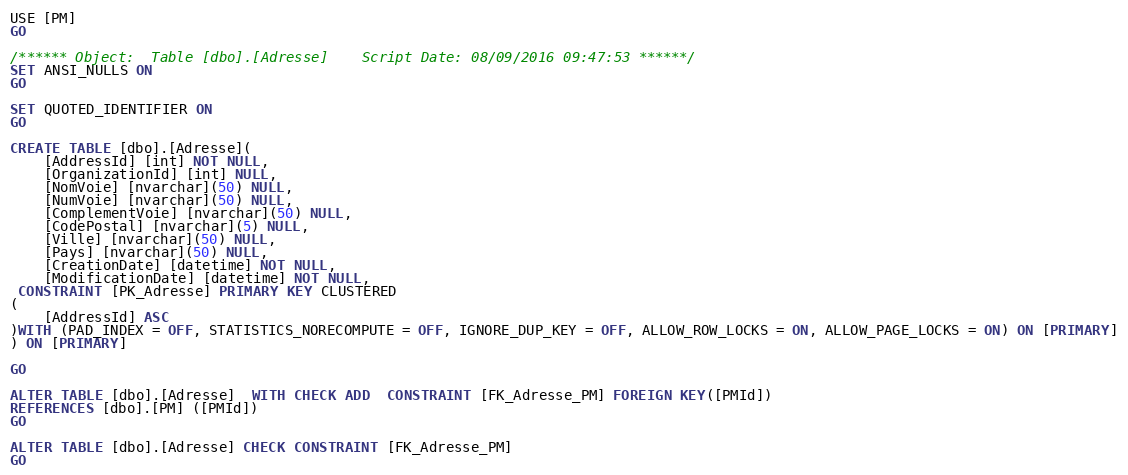Convert code to text. <code><loc_0><loc_0><loc_500><loc_500><_SQL_>USE [PM]
GO

/****** Object:  Table [dbo].[Adresse]    Script Date: 08/09/2016 09:47:53 ******/
SET ANSI_NULLS ON
GO

SET QUOTED_IDENTIFIER ON
GO

CREATE TABLE [dbo].[Adresse](
	[AddressId] [int] NOT NULL,
	[OrganizationId] [int] NULL,
	[NomVoie] [nvarchar](50) NULL,
	[NumVoie] [nvarchar](50) NULL,
	[ComplementVoie] [nvarchar](50) NULL,
	[CodePostal] [nvarchar](5) NULL,
	[Ville] [nvarchar](50) NULL,
	[Pays] [nvarchar](50) NULL,
	[CreationDate] [datetime] NOT NULL,
	[ModificationDate] [datetime] NOT NULL,
 CONSTRAINT [PK_Adresse] PRIMARY KEY CLUSTERED 
(
	[AddressId] ASC
)WITH (PAD_INDEX = OFF, STATISTICS_NORECOMPUTE = OFF, IGNORE_DUP_KEY = OFF, ALLOW_ROW_LOCKS = ON, ALLOW_PAGE_LOCKS = ON) ON [PRIMARY]
) ON [PRIMARY]

GO

ALTER TABLE [dbo].[Adresse]  WITH CHECK ADD  CONSTRAINT [FK_Adresse_PM] FOREIGN KEY([PMId])
REFERENCES [dbo].[PM] ([PMId])
GO

ALTER TABLE [dbo].[Adresse] CHECK CONSTRAINT [FK_Adresse_PM]
GO


</code> 